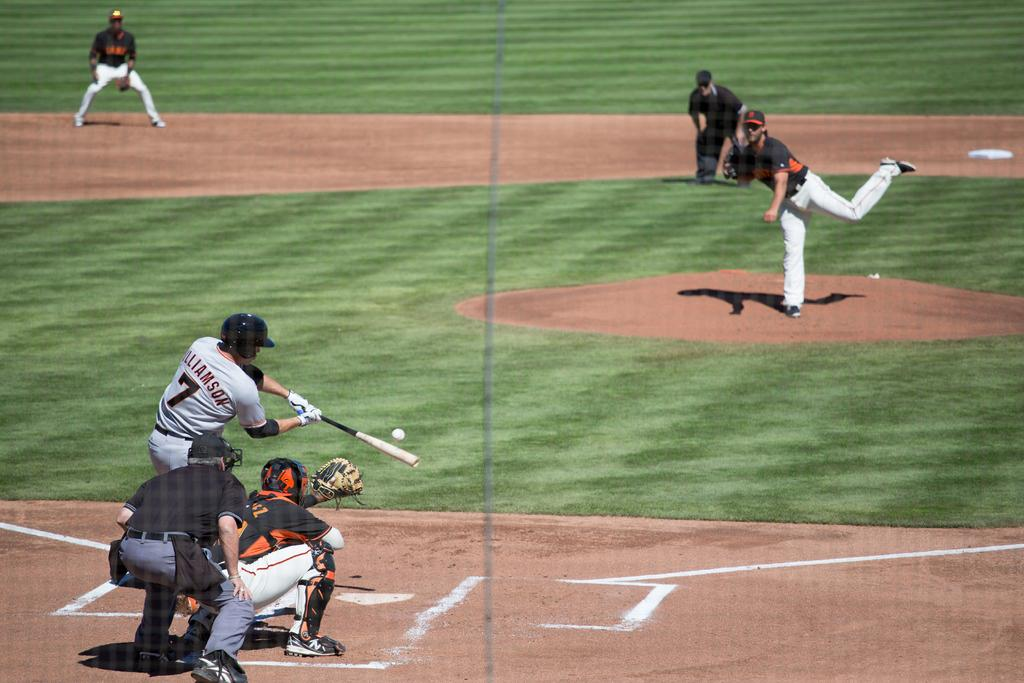What type of location is shown in the image? The image depicts a playground. What activity are the people engaged in at the playground? People are playing baseball in the image. Can you describe the man's attire in the image? The man is wearing a helmet and gloves. What is the man holding in the image? The man is holding a baseball bat. What is happening with the baseball in the image? A baseball is visible in the air. Who is the representative of the playground in the image? There is no specific representative of the playground in the image; it is a general scene of people playing baseball. Can you tell me what type of oven is present in the image? There is no oven present in the image; it depicts a playground with people playing baseball. 